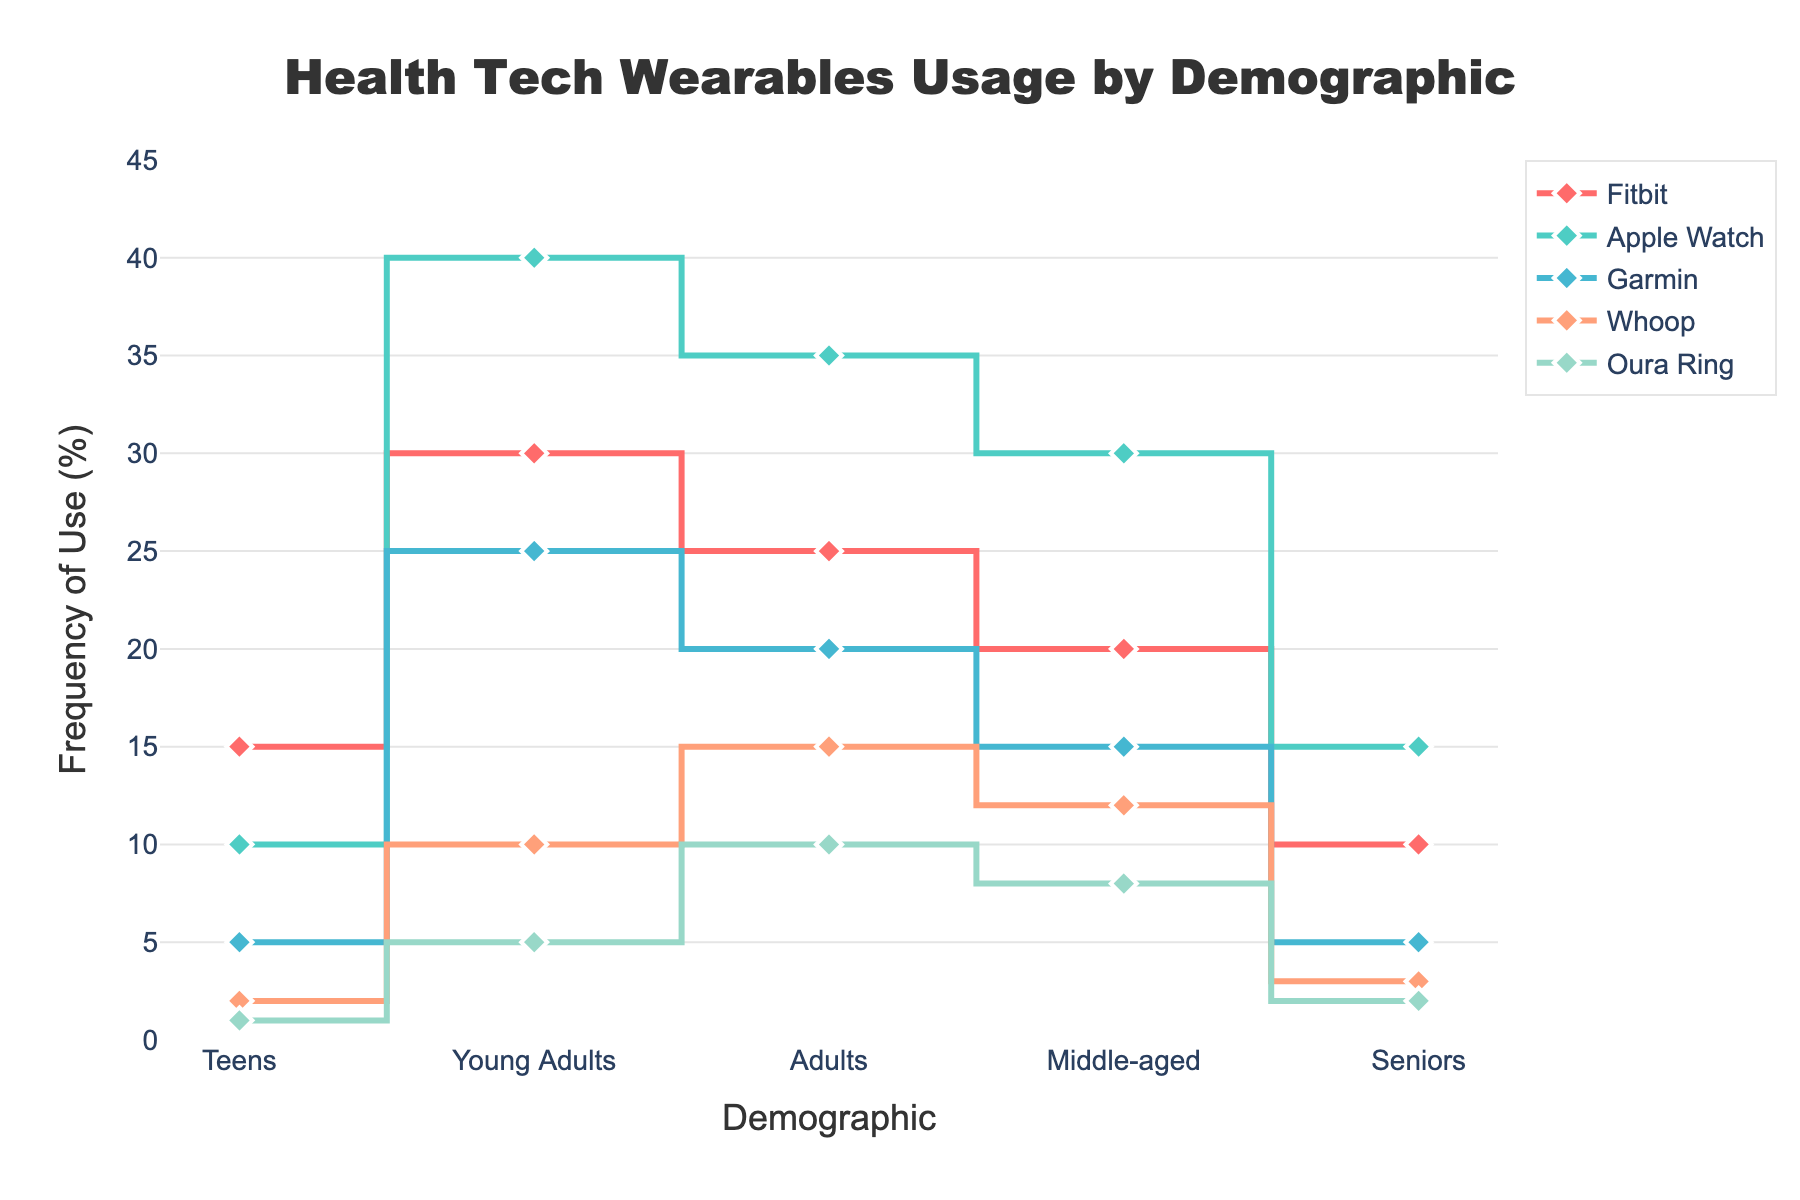How many demographics are displayed in the plot? The plot shows the frequency of use of health tech wearables across different demographic groups. Upon counting, there are five demographic groups displayed on the x-axis.
Answer: Five What is the most used wearable in the "Young Adults" demographic? By inspecting the Young Adults category on the x-axis, the frequency of use for each wearable can be seen. Among them, the Apple Watch is the most used with a frequency of 40%.
Answer: Apple Watch Which demographic has the highest use of the Oura Ring? By observing the heights of the markers for each demographic in the Oura Ring category, the Adults demographic has the highest value at 10%.
Answer: Adults What is the frequency difference of Fitbit usage between Teens and Adults? The plot shows that the frequency of Fitbit use for Teens is 15%, while for Adults it is 25%. The difference can be calculated by subtracting the lower value from the higher one, which is 25% - 15% = 10%.
Answer: 10% Which wearable has the least use in the Middle-aged demographic? By looking at the Middle-aged category, the wearable with the lowest frequency of use is the Garmin, at 5%.
Answer: Garmin Among the demographics, who uses the Whoop wearable the most? Inspecting each demographic for the Whoop wearable, the Adults demographic has the highest frequency of use at 15%.
Answer: Adults What is the sum of the frequencies of Apple Watch usage across all demographics? Summing up the frequencies of Apple Watch usage: Teens (10%) + Young Adults (40%) + Adults (35%) + Middle-aged (30%) + Seniors (15%) = 130%.
Answer: 130% Compare the frequency of use of Garmin between Young Adults and Middle-aged demographics. Which group has a higher frequency? Observing the Garmin category, Young Adults show a usage frequency of 25% while Middle-aged shows 15%. Therefore, Young Adults have a higher frequency of use.
Answer: Young Adults What is the average frequency of use for Whoop across all demographics? To find the average frequency, sum the values for all demographics and divide by the number of demographics: (Teens: 2% + Young Adults: 10% + Adults: 15% + Middle-aged: 12% + Seniors: 3%) / 5 = 8.4%.
Answer: 8.4% Is the frequency of use for the Fitbit higher or lower than the Apple Watch for Seniors? By comparing the frequency values in the Seniors demographic, Fitbit usage is at 10% while Apple Watch usage is at 15%. Therefore, Fitbit usage is lower.
Answer: Lower 